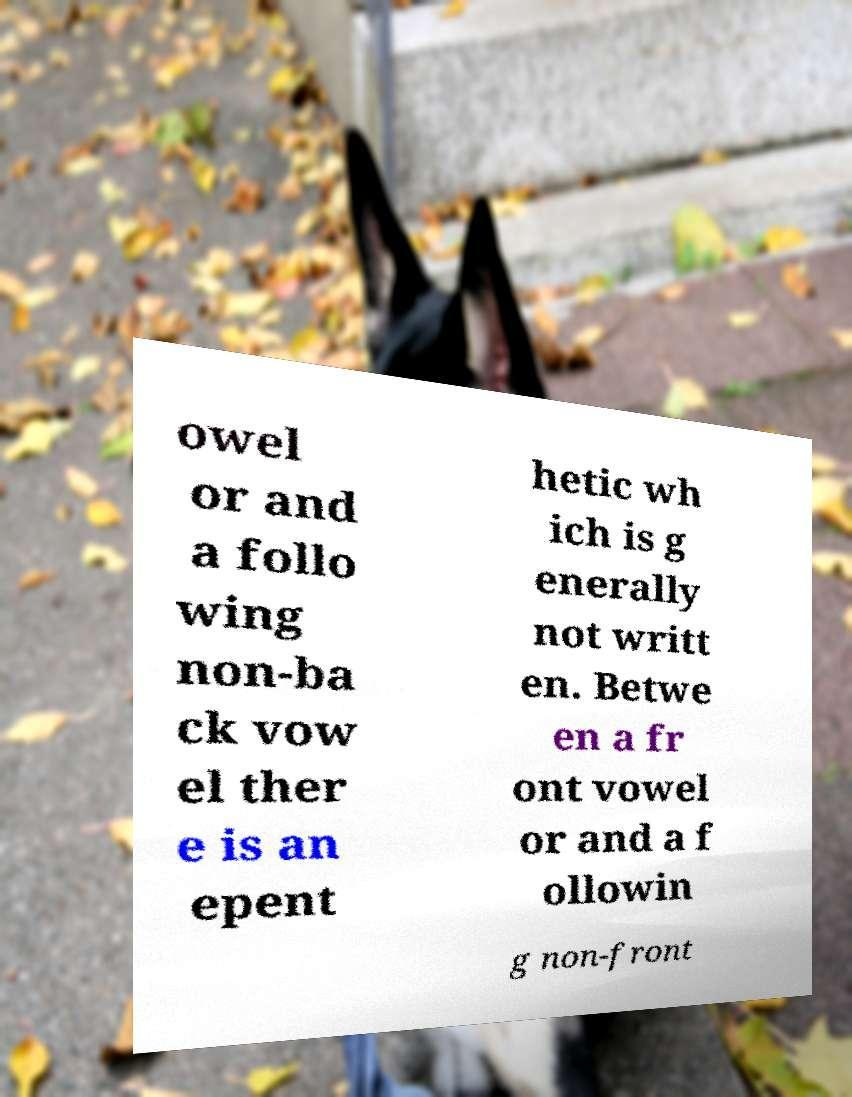Can you accurately transcribe the text from the provided image for me? owel or and a follo wing non-ba ck vow el ther e is an epent hetic wh ich is g enerally not writt en. Betwe en a fr ont vowel or and a f ollowin g non-front 